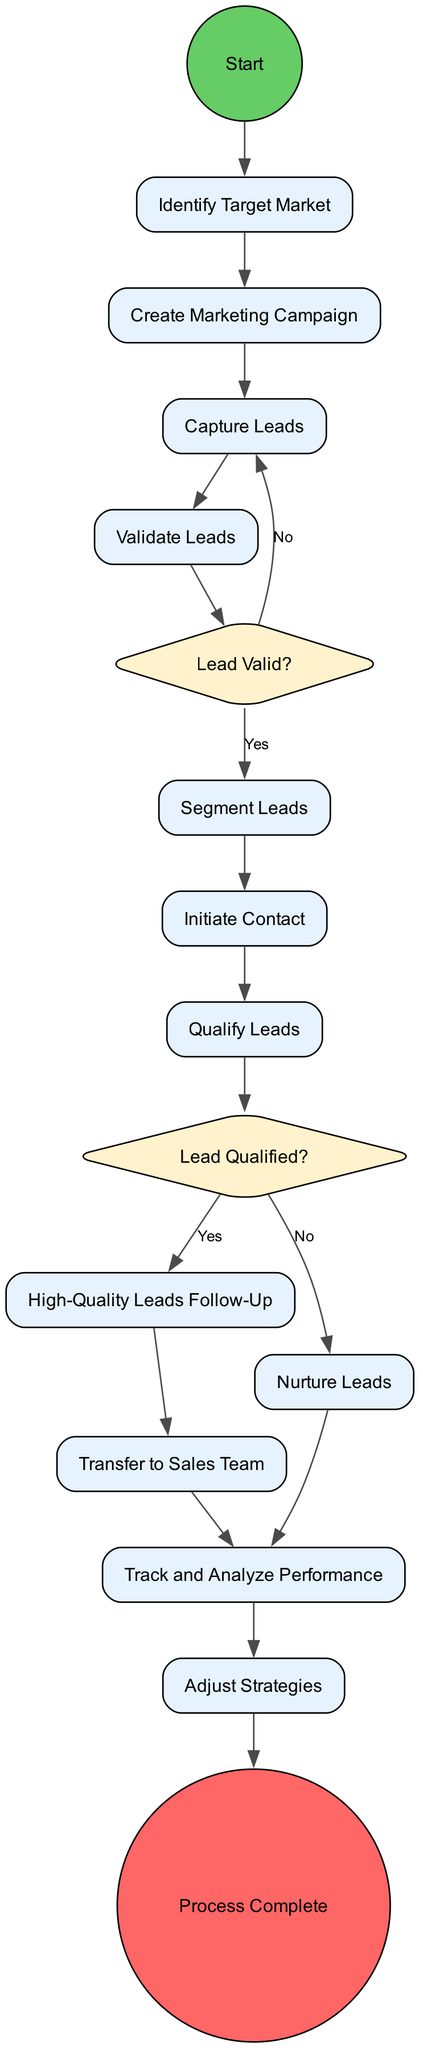What is the first activity in the diagram? The first activity node connected to the start node is "Identify Target Market," which is the initial step in the lead generation and qualification process.
Answer: Identify Target Market How many decision points are in the diagram? There are two decision points labeled "Lead Valid?" and "Lead Qualified?" that guide the flow based on criteria.
Answer: 2 What activity follows after "Capture Leads"? After "Capture Leads," the next activity connected in the sequence is "Validate Leads," as it is the direct continuation of the process.
Answer: Validate Leads What happens if a lead is not valid? If a lead is not valid, the flow directs back to "Capture Leads," indicating that it should try to collect lead information again.
Answer: Capture Leads Which activity occurs after "Qualify Leads" if the lead is not qualified? If the lead is not qualified based on the criteria, the flow moves to "Nurture Leads," which involves maintaining communication with the lead.
Answer: Nurture Leads What is the last step before the process is complete? The last step before the process is complete is "Adjust Strategies," which is designed to refine lead generation tactics based on performance data before concluding the process.
Answer: Adjust Strategies What activity does the "High-Quality Leads Follow-Up" lead to? The "High-Quality Leads Follow-Up" activity leads to "Transfer to Sales Team," indicating the transition to sales efforts for promising leads.
Answer: Transfer to Sales Team How do qualified leads proceed in the flow? Qualified leads proceed directly to "High-Quality Leads Follow-Up," reflecting that they are ready for further engagement and sales discussion.
Answer: High-Quality Leads Follow-Up What is the outcome of the process? The outcome of the process is labeled as "Process Complete," which signifies the end of lead generation and qualification journey.
Answer: Process Complete 